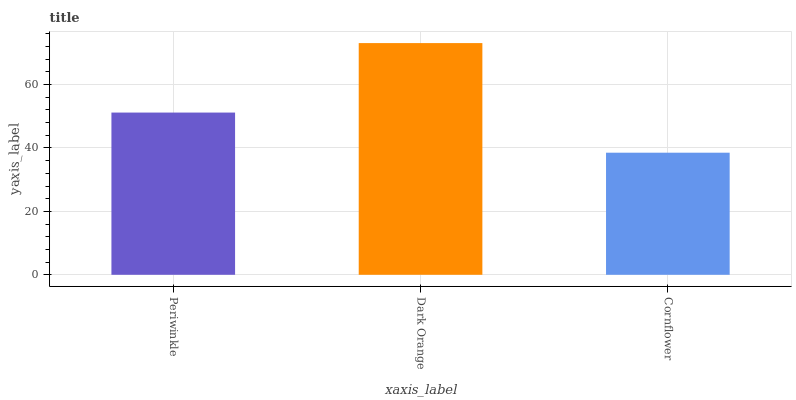Is Cornflower the minimum?
Answer yes or no. Yes. Is Dark Orange the maximum?
Answer yes or no. Yes. Is Dark Orange the minimum?
Answer yes or no. No. Is Cornflower the maximum?
Answer yes or no. No. Is Dark Orange greater than Cornflower?
Answer yes or no. Yes. Is Cornflower less than Dark Orange?
Answer yes or no. Yes. Is Cornflower greater than Dark Orange?
Answer yes or no. No. Is Dark Orange less than Cornflower?
Answer yes or no. No. Is Periwinkle the high median?
Answer yes or no. Yes. Is Periwinkle the low median?
Answer yes or no. Yes. Is Cornflower the high median?
Answer yes or no. No. Is Cornflower the low median?
Answer yes or no. No. 